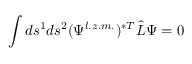<formula> <loc_0><loc_0><loc_500><loc_500>\int d s ^ { 1 } d s ^ { 2 } ( \Psi ^ { l . z . m . } ) ^ { \ast T } \hat { L } \Psi = 0</formula> 